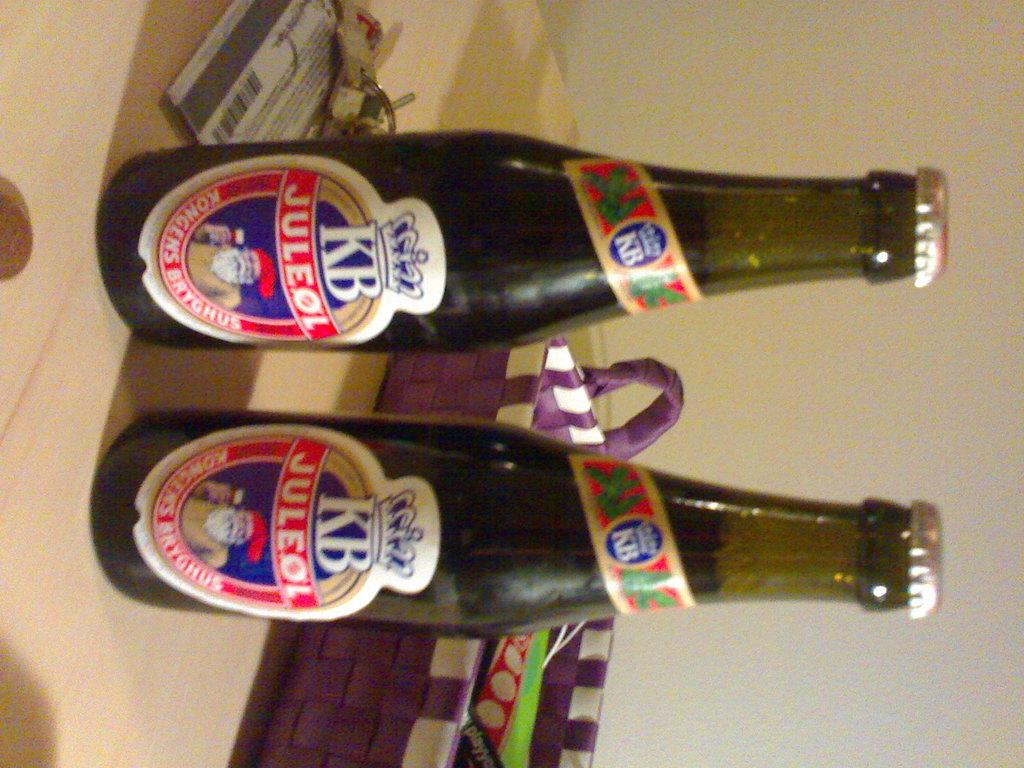<image>
Present a compact description of the photo's key features. two bottles of KB Juleol on a table 